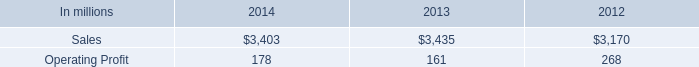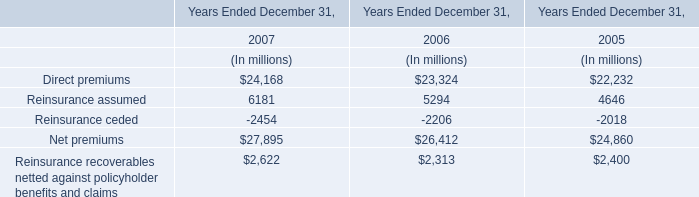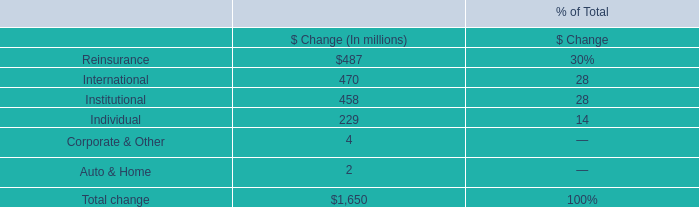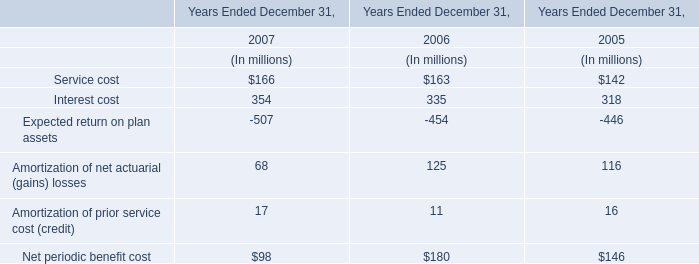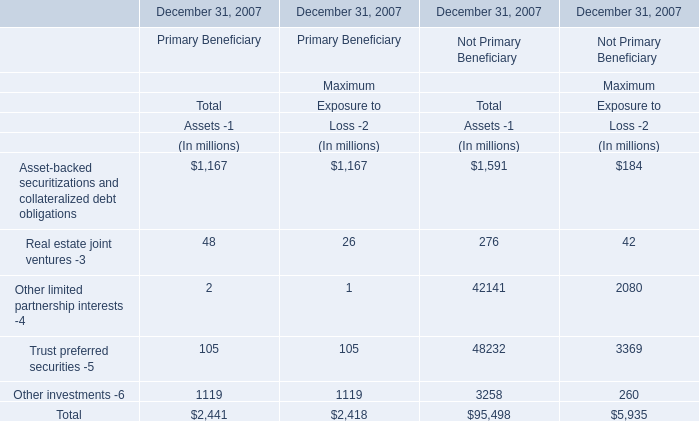How many Maximum Exposure to Loss -2 of Primary Beneficiary exceed the average of Maximum Exposure to Loss -2 of Primary Beneficiary in 2007? 
Answer: 2. 